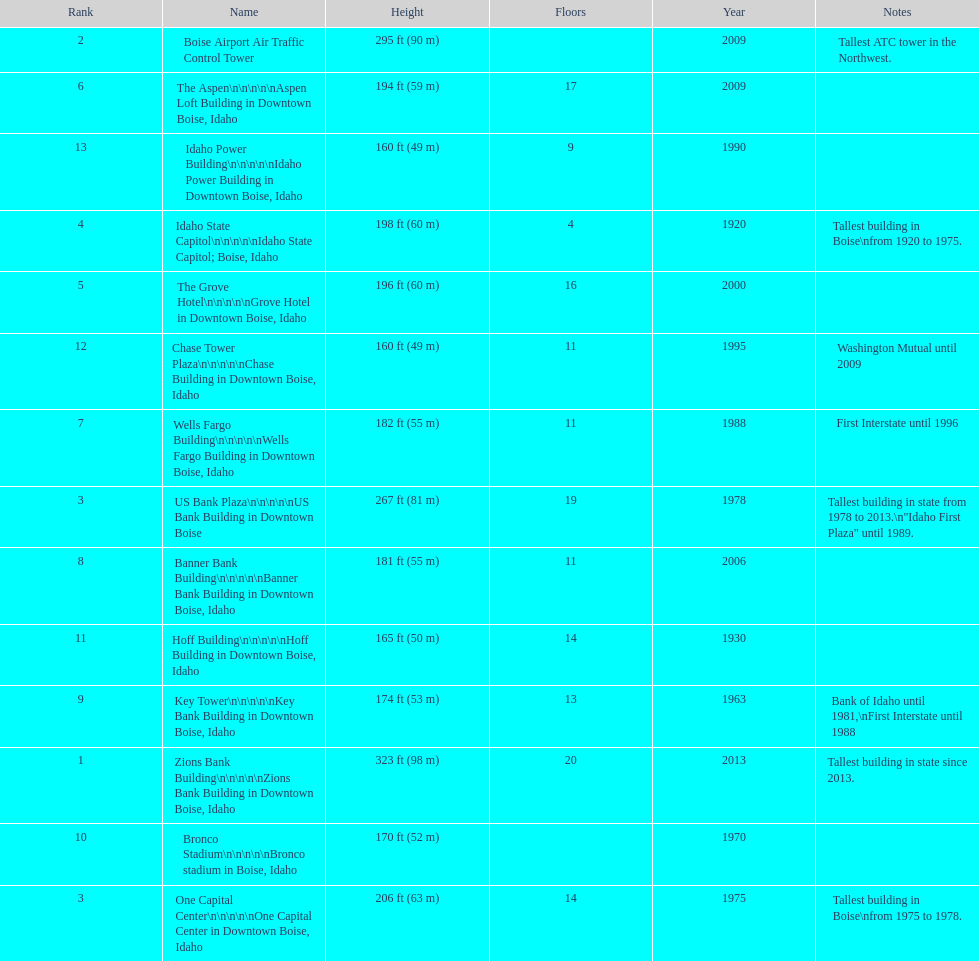How many buildings have at least ten floors? 10. 